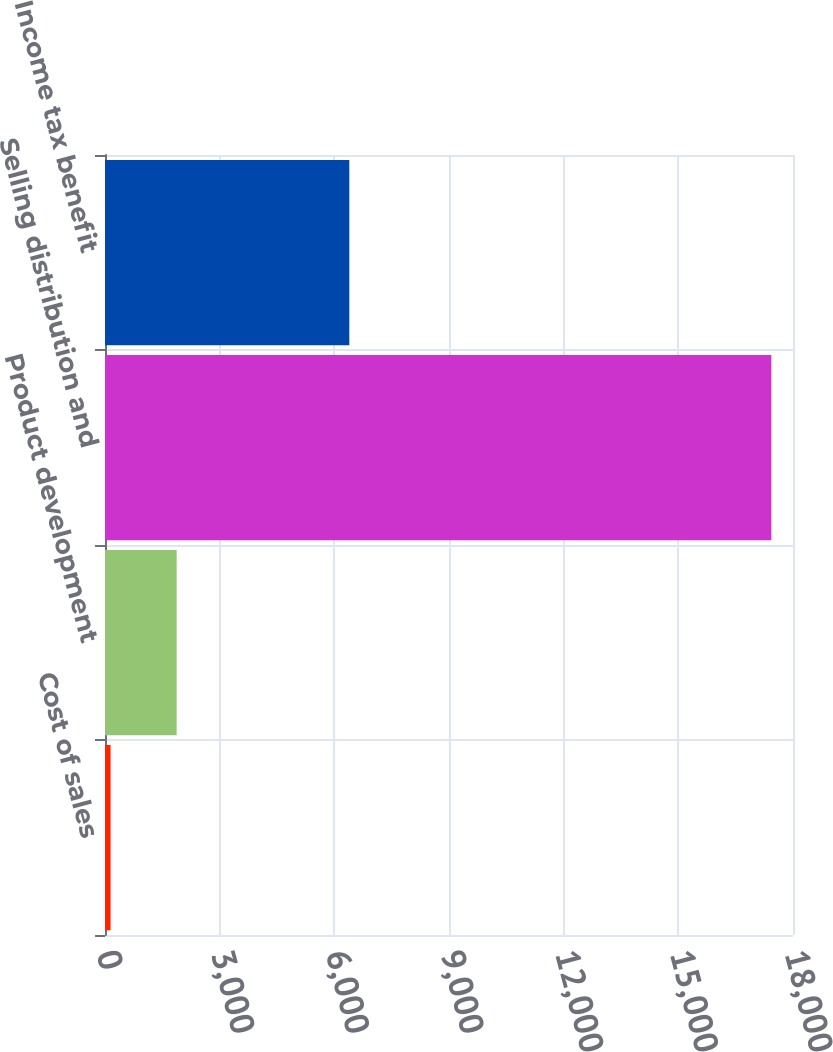<chart> <loc_0><loc_0><loc_500><loc_500><bar_chart><fcel>Cost of sales<fcel>Product development<fcel>Selling distribution and<fcel>Income tax benefit<nl><fcel>146<fcel>1874.8<fcel>17434<fcel>6392<nl></chart> 